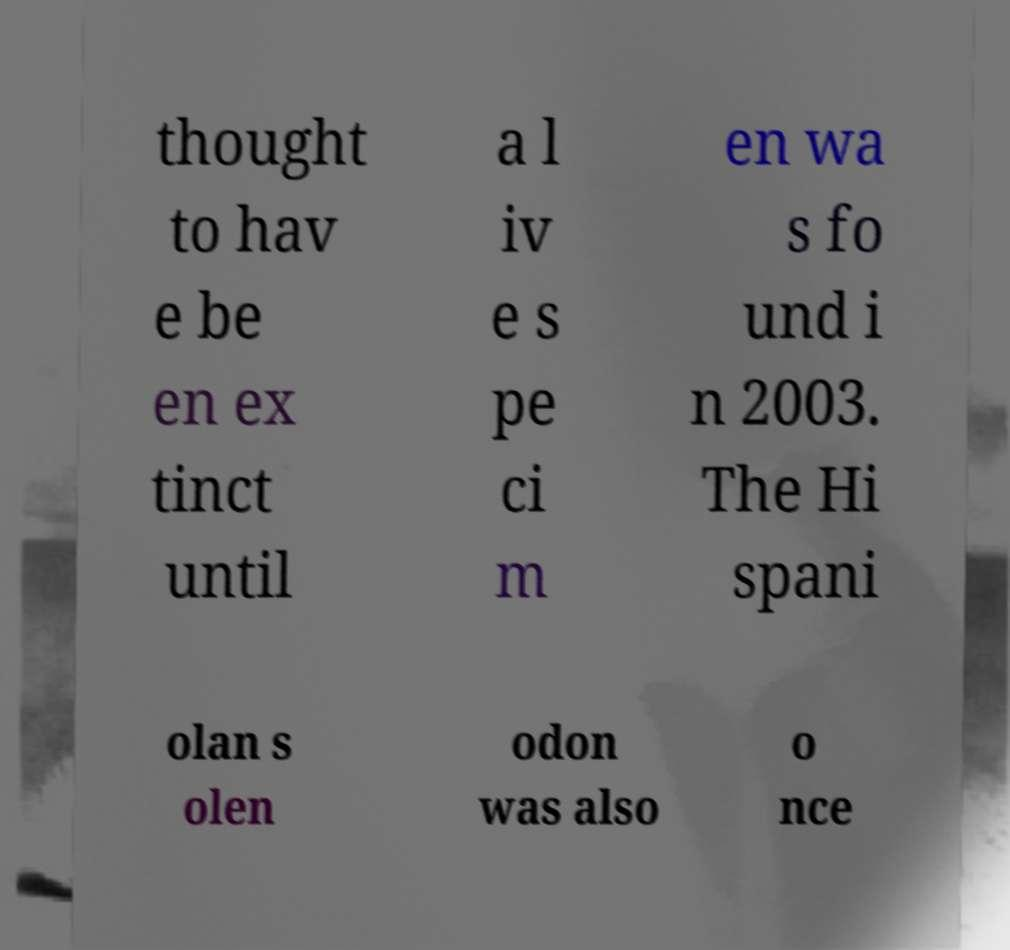Can you read and provide the text displayed in the image?This photo seems to have some interesting text. Can you extract and type it out for me? thought to hav e be en ex tinct until a l iv e s pe ci m en wa s fo und i n 2003. The Hi spani olan s olen odon was also o nce 